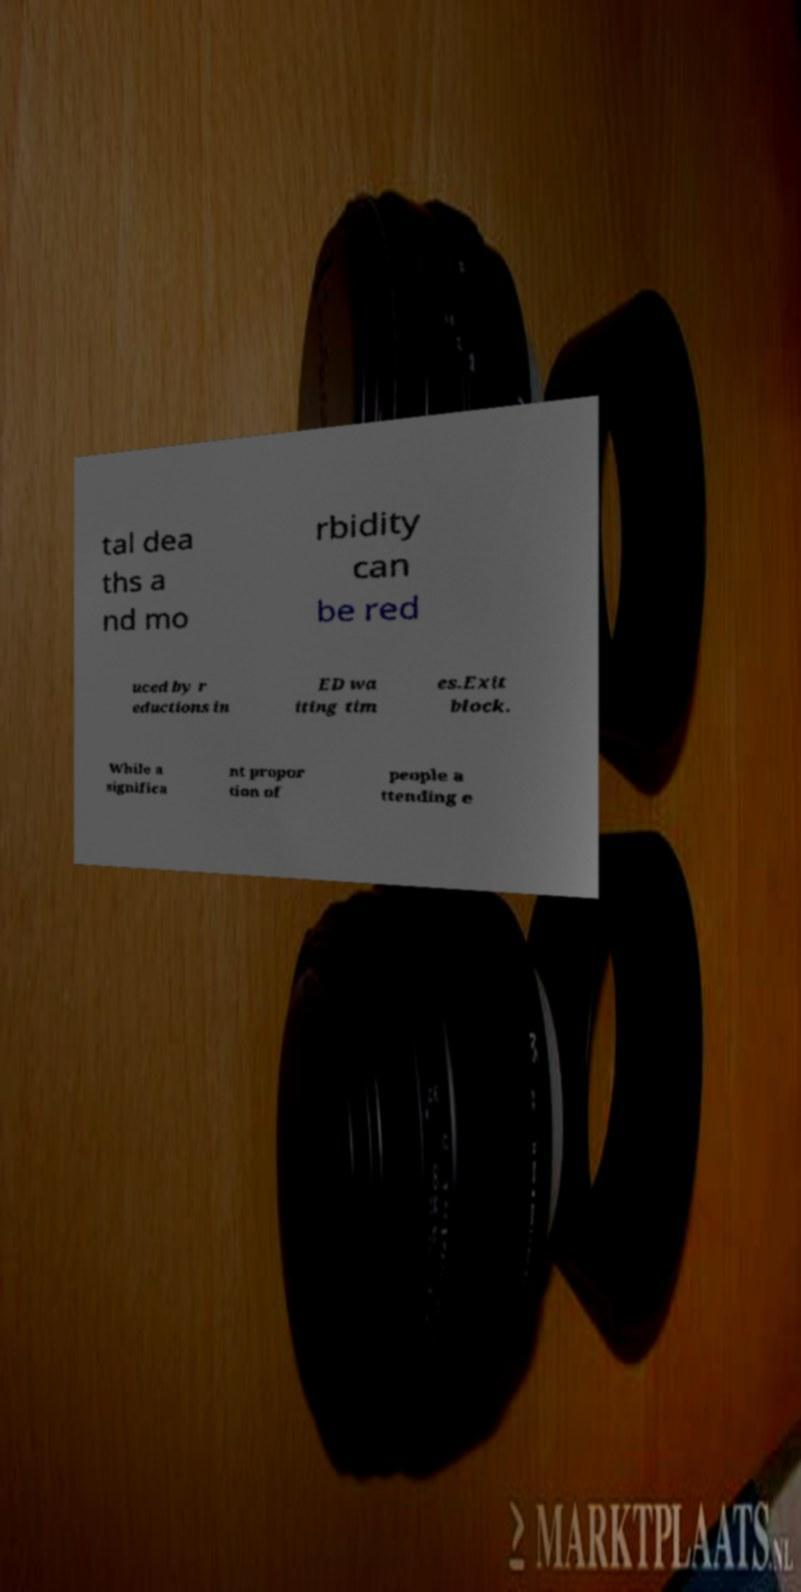I need the written content from this picture converted into text. Can you do that? tal dea ths a nd mo rbidity can be red uced by r eductions in ED wa iting tim es.Exit block. While a significa nt propor tion of people a ttending e 